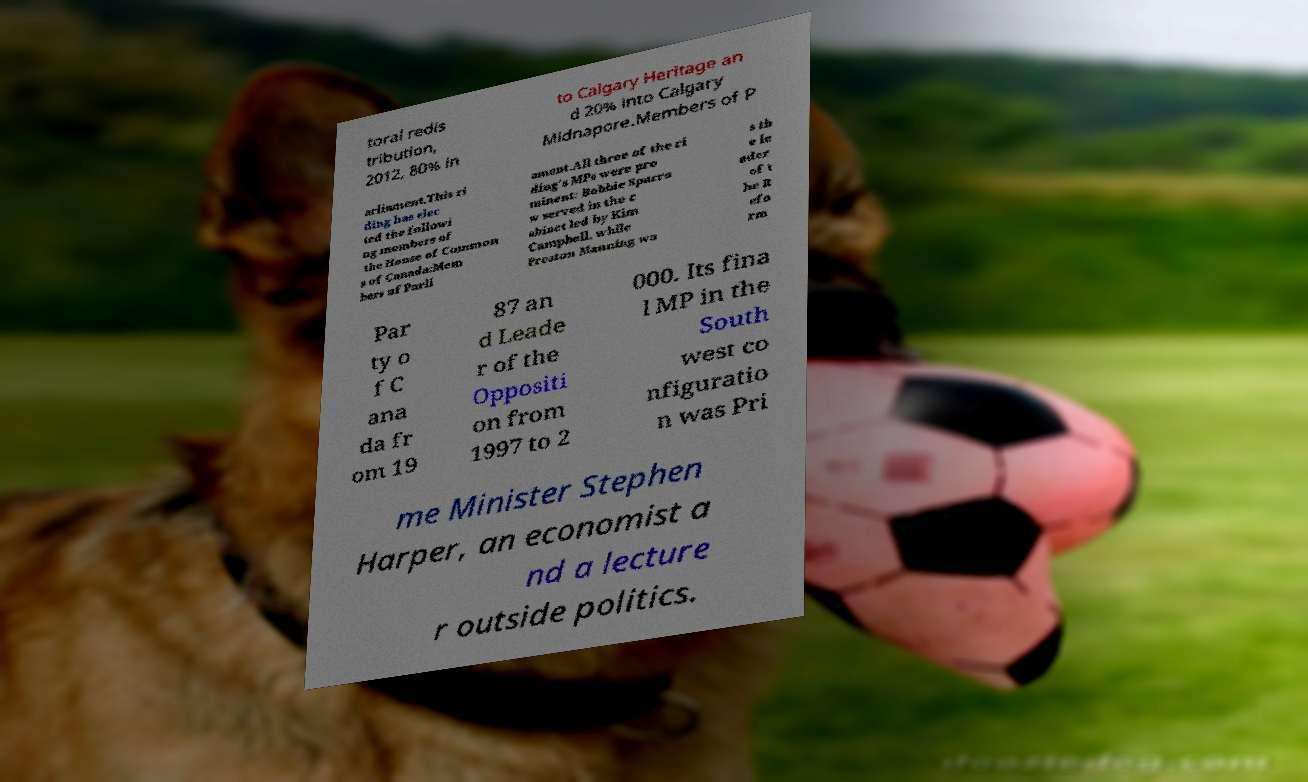I need the written content from this picture converted into text. Can you do that? toral redis tribution, 2012, 80% in to Calgary Heritage an d 20% into Calgary Midnapore.Members of P arliament.This ri ding has elec ted the followi ng members of the House of Common s of Canada:Mem bers of Parli ament.All three of the ri ding's MPs were pro minent: Bobbie Sparro w served in the c abinet led by Kim Campbell, while Preston Manning wa s th e le ader of t he R efo rm Par ty o f C ana da fr om 19 87 an d Leade r of the Oppositi on from 1997 to 2 000. Its fina l MP in the South west co nfiguratio n was Pri me Minister Stephen Harper, an economist a nd a lecture r outside politics. 